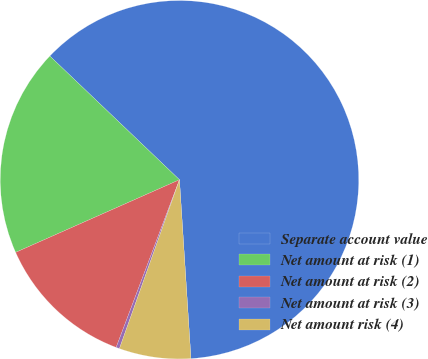<chart> <loc_0><loc_0><loc_500><loc_500><pie_chart><fcel>Separate account value<fcel>Net amount at risk (1)<fcel>Net amount at risk (2)<fcel>Net amount at risk (3)<fcel>Net amount risk (4)<nl><fcel>61.85%<fcel>18.77%<fcel>12.61%<fcel>0.31%<fcel>6.46%<nl></chart> 